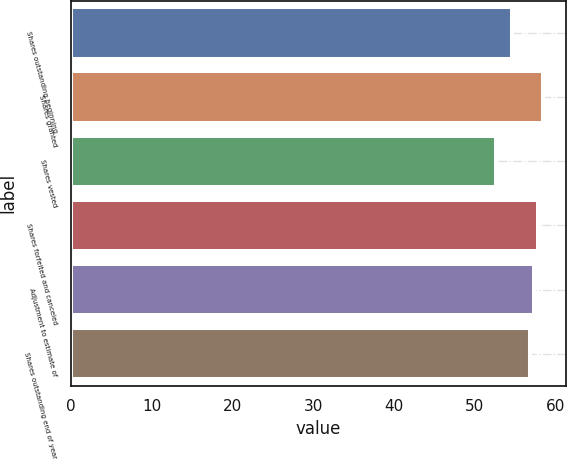<chart> <loc_0><loc_0><loc_500><loc_500><bar_chart><fcel>Shares outstanding beginning<fcel>Shares granted<fcel>Shares vested<fcel>Shares forfeited and canceled<fcel>Adjustment to estimate of<fcel>Shares outstanding end of year<nl><fcel>54.61<fcel>58.4<fcel>52.62<fcel>57.88<fcel>57.36<fcel>56.84<nl></chart> 